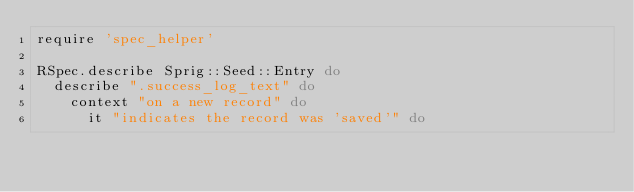Convert code to text. <code><loc_0><loc_0><loc_500><loc_500><_Ruby_>require 'spec_helper'

RSpec.describe Sprig::Seed::Entry do
  describe ".success_log_text" do
    context "on a new record" do
      it "indicates the record was 'saved'" do</code> 